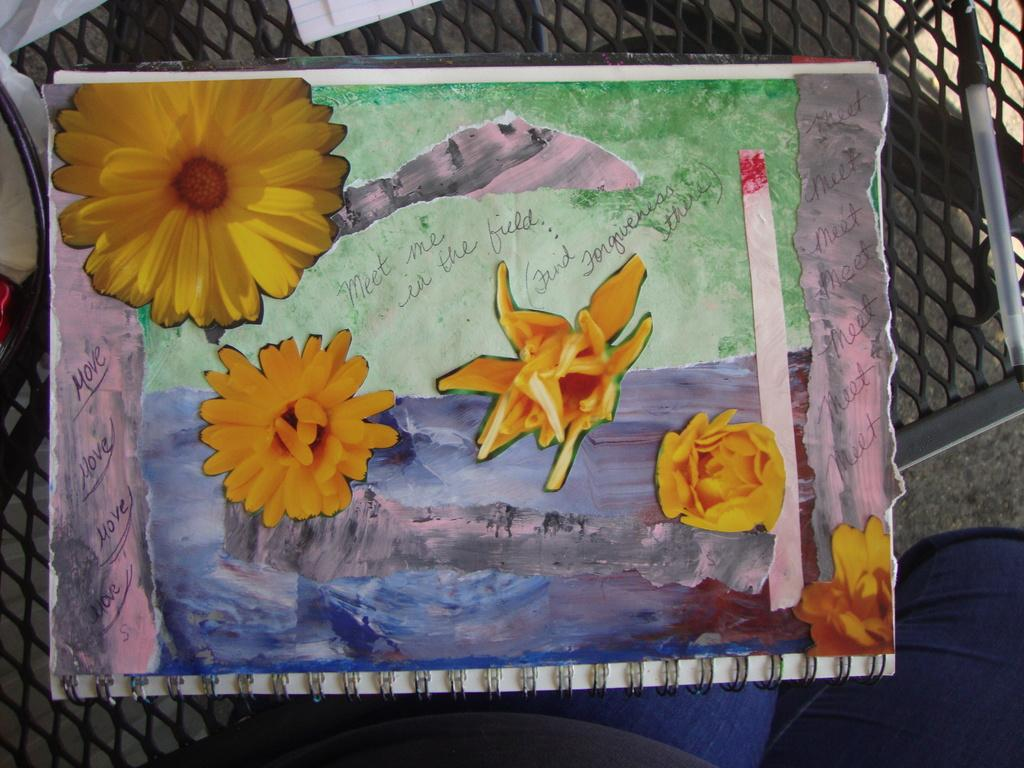What is the main subject in the front of the image? There is a paper in the front of the image. What is depicted on the paper? The paper has a painting of flowers on it. Are there any words on the paper? Yes, there is text on the paper. What can be seen on the right side of the image? There is a pen on the right side of the image. What type of furniture is visible at the bottom of the image? It appears to be a chair at the bottom of the image. What shape is the earth depicted as in the image? The image does not depict the earth; it features a paper with a painting of flowers and text. Who is the achiever mentioned in the text on the paper? The text on the paper does not mention any specific achiever. 